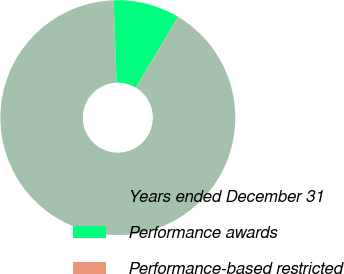<chart> <loc_0><loc_0><loc_500><loc_500><pie_chart><fcel>Years ended December 31<fcel>Performance awards<fcel>Performance-based restricted<nl><fcel>90.73%<fcel>9.17%<fcel>0.1%<nl></chart> 